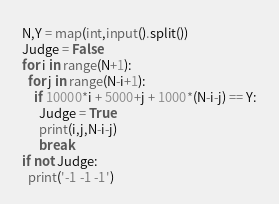Convert code to text. <code><loc_0><loc_0><loc_500><loc_500><_Python_>N,Y = map(int,input().split())
Judge = False
for i in range(N+1):
  for j in range(N-i+1):
    if 10000*i + 5000+j + 1000*(N-i-j) == Y:
      Judge = True
      print(i,j,N-i-j)
      break
if not Judge:
  print('-1 -1 -1')</code> 